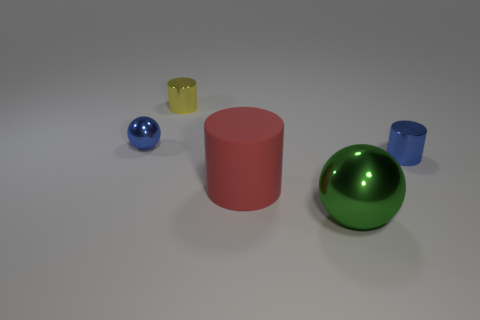What number of green balls have the same size as the matte object? There is one green ball in the image, and it appears to be the same size as the matte red cylindrical object. 